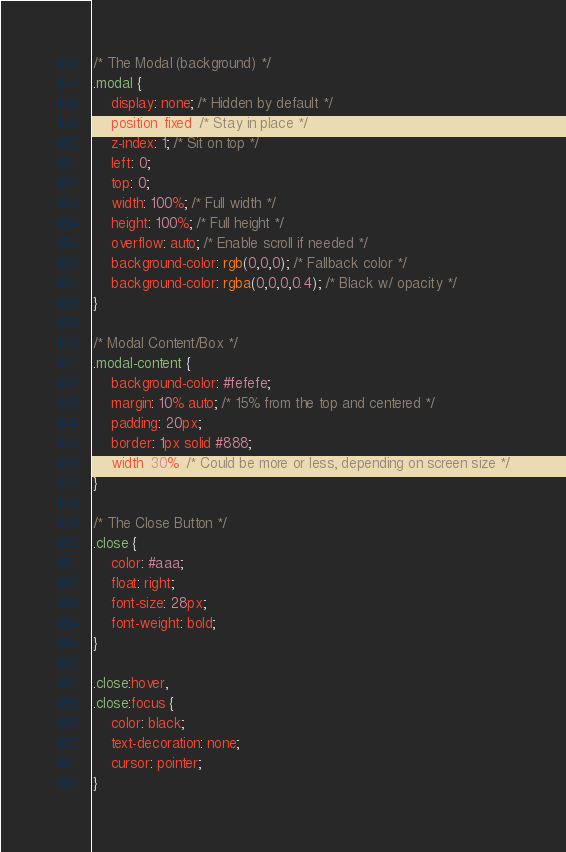<code> <loc_0><loc_0><loc_500><loc_500><_CSS_>/* The Modal (background) */
.modal {
    display: none; /* Hidden by default */
    position: fixed; /* Stay in place */
    z-index: 1; /* Sit on top */
    left: 0;
    top: 0;
    width: 100%; /* Full width */
    height: 100%; /* Full height */
    overflow: auto; /* Enable scroll if needed */
    background-color: rgb(0,0,0); /* Fallback color */
    background-color: rgba(0,0,0,0.4); /* Black w/ opacity */
}

/* Modal Content/Box */
.modal-content {
    background-color: #fefefe;
    margin: 10% auto; /* 15% from the top and centered */
    padding: 20px;
    border: 1px solid #888;
    width: 30%; /* Could be more or less, depending on screen size */
}

/* The Close Button */
.close {
    color: #aaa;
    float: right;
    font-size: 28px;
    font-weight: bold;
}

.close:hover,
.close:focus {
    color: black;
    text-decoration: none;
    cursor: pointer;
}
</code> 